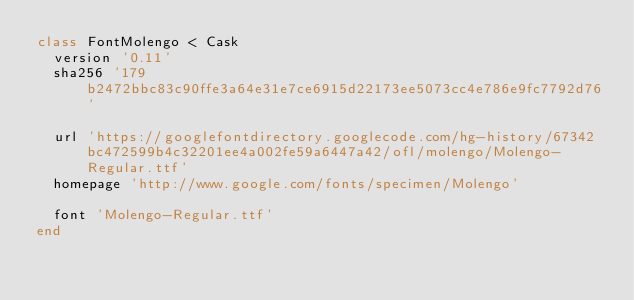Convert code to text. <code><loc_0><loc_0><loc_500><loc_500><_Ruby_>class FontMolengo < Cask
  version '0.11'
  sha256 '179b2472bbc83c90ffe3a64e31e7ce6915d22173ee5073cc4e786e9fc7792d76'

  url 'https://googlefontdirectory.googlecode.com/hg-history/67342bc472599b4c32201ee4a002fe59a6447a42/ofl/molengo/Molengo-Regular.ttf'
  homepage 'http://www.google.com/fonts/specimen/Molengo'

  font 'Molengo-Regular.ttf'
end
</code> 